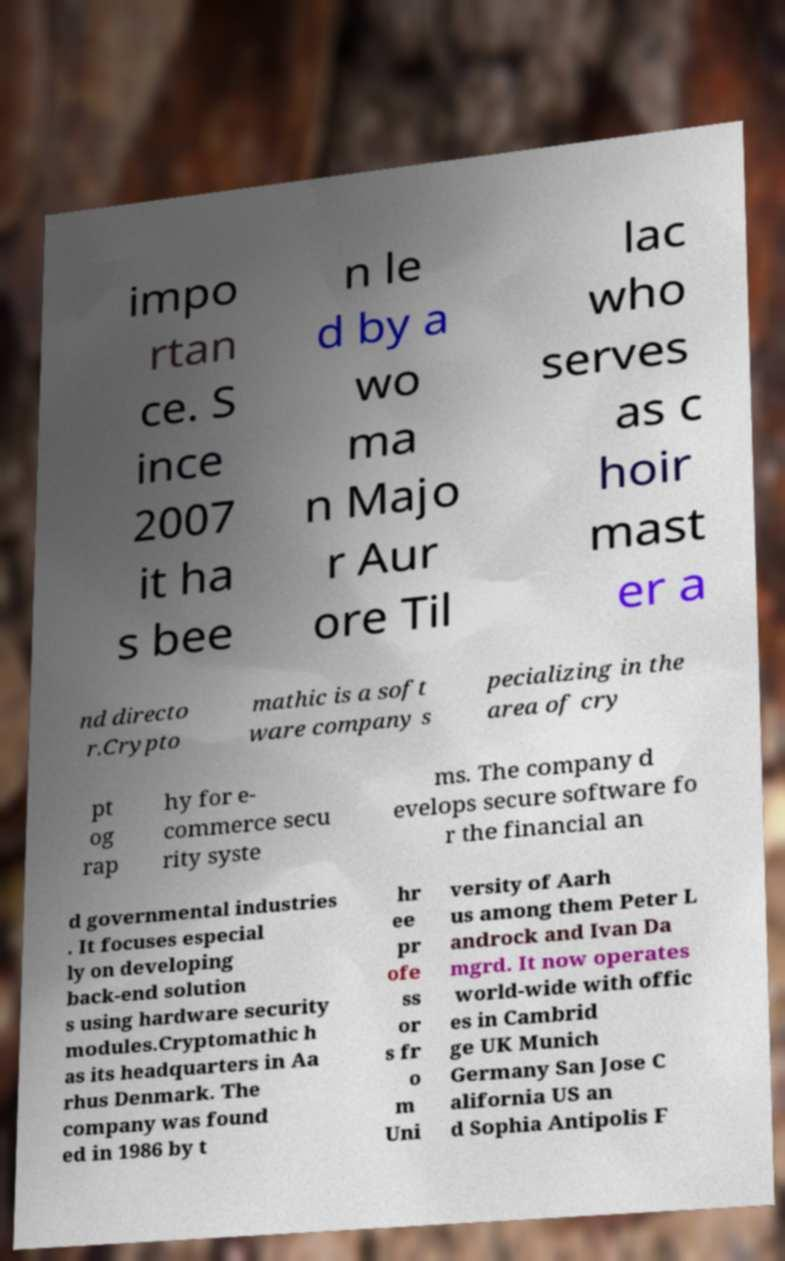What messages or text are displayed in this image? I need them in a readable, typed format. impo rtan ce. S ince 2007 it ha s bee n le d by a wo ma n Majo r Aur ore Til lac who serves as c hoir mast er a nd directo r.Crypto mathic is a soft ware company s pecializing in the area of cry pt og rap hy for e- commerce secu rity syste ms. The company d evelops secure software fo r the financial an d governmental industries . It focuses especial ly on developing back-end solution s using hardware security modules.Cryptomathic h as its headquarters in Aa rhus Denmark. The company was found ed in 1986 by t hr ee pr ofe ss or s fr o m Uni versity of Aarh us among them Peter L androck and Ivan Da mgrd. It now operates world-wide with offic es in Cambrid ge UK Munich Germany San Jose C alifornia US an d Sophia Antipolis F 